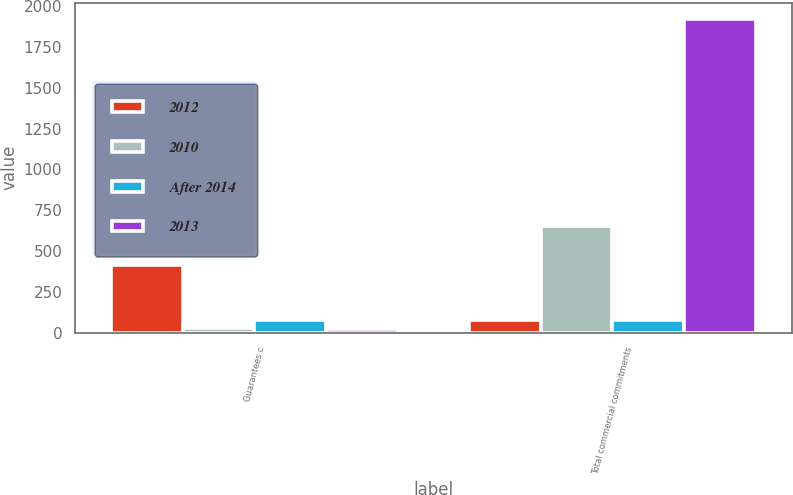Convert chart to OTSL. <chart><loc_0><loc_0><loc_500><loc_500><stacked_bar_chart><ecel><fcel>Guarantees c<fcel>Total commercial commitments<nl><fcel>2012<fcel>416<fcel>76<nl><fcel>2010<fcel>29<fcel>651<nl><fcel>After 2014<fcel>76<fcel>76<nl><fcel>2013<fcel>24<fcel>1924<nl></chart> 